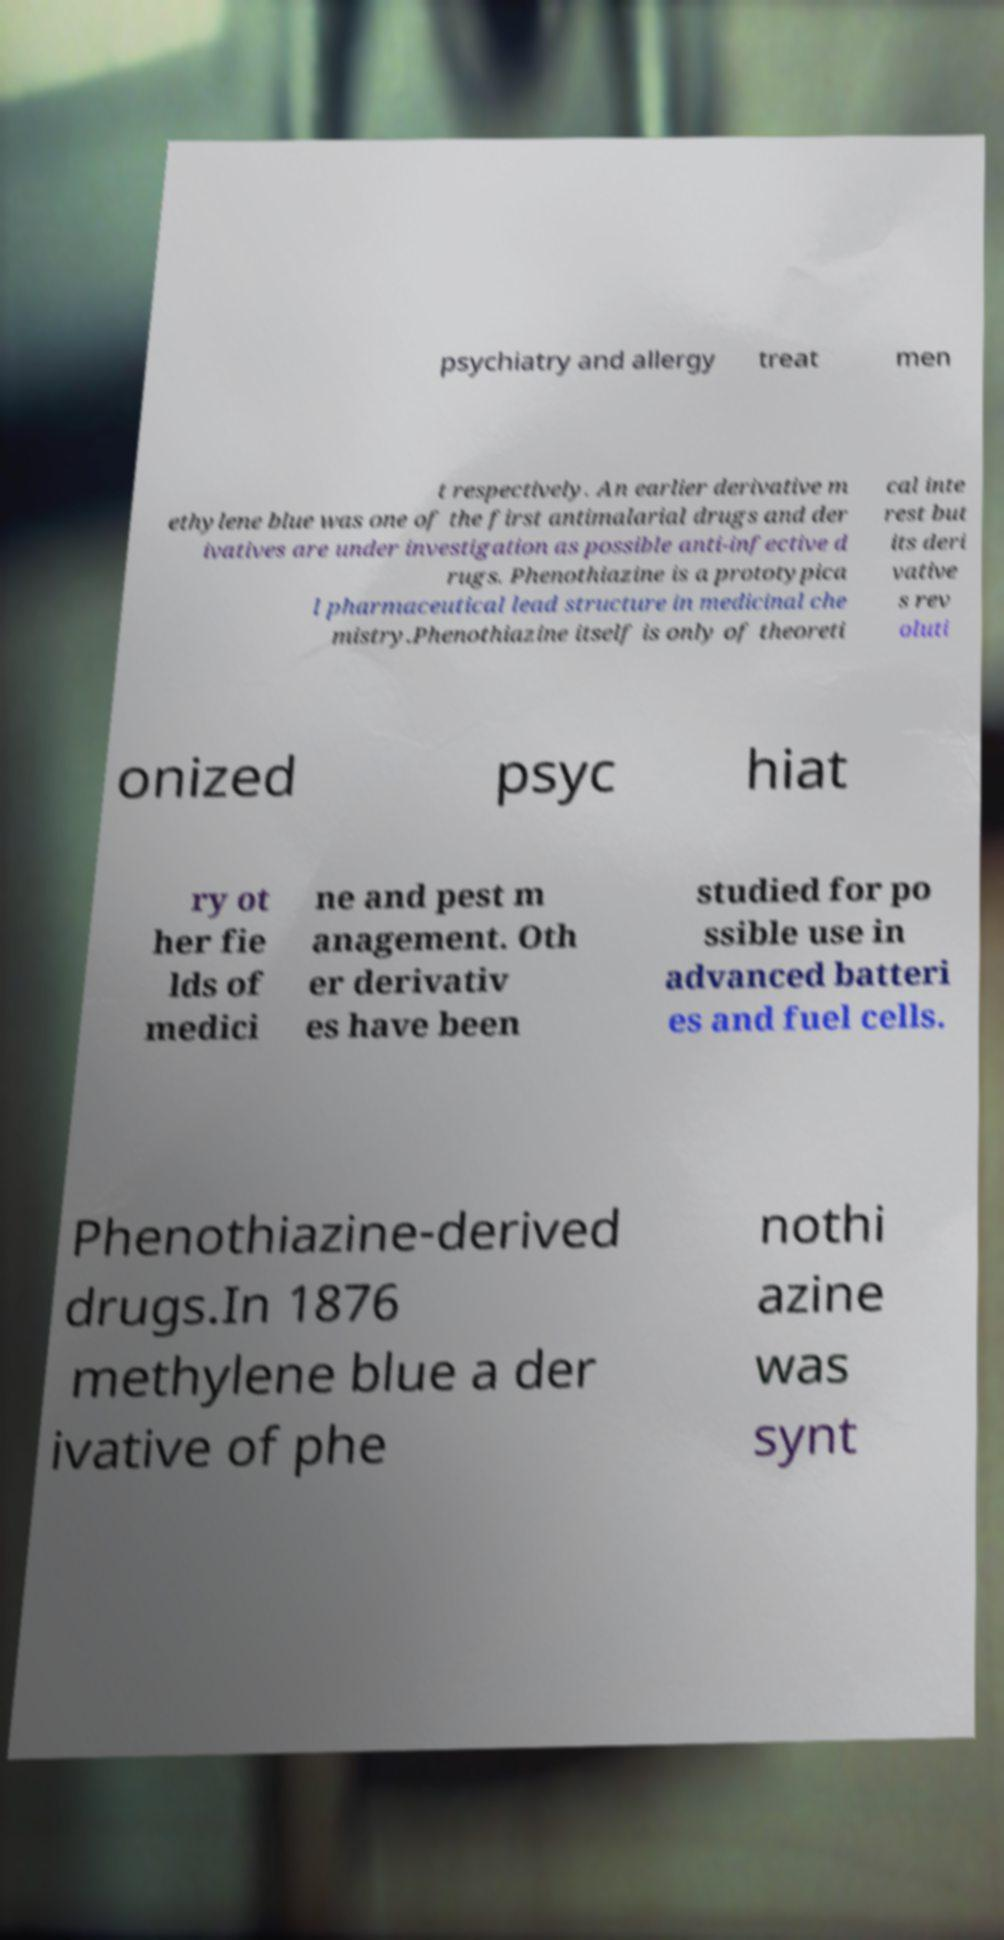There's text embedded in this image that I need extracted. Can you transcribe it verbatim? psychiatry and allergy treat men t respectively. An earlier derivative m ethylene blue was one of the first antimalarial drugs and der ivatives are under investigation as possible anti-infective d rugs. Phenothiazine is a prototypica l pharmaceutical lead structure in medicinal che mistry.Phenothiazine itself is only of theoreti cal inte rest but its deri vative s rev oluti onized psyc hiat ry ot her fie lds of medici ne and pest m anagement. Oth er derivativ es have been studied for po ssible use in advanced batteri es and fuel cells. Phenothiazine-derived drugs.In 1876 methylene blue a der ivative of phe nothi azine was synt 